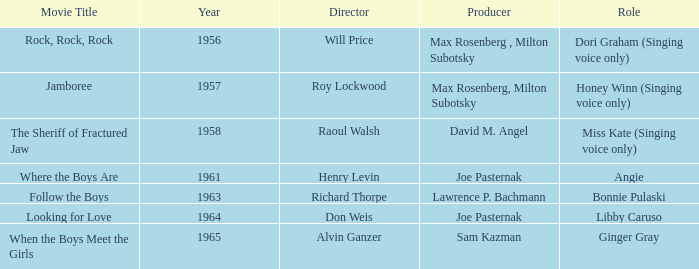What movie was made in 1957? Jamboree. 